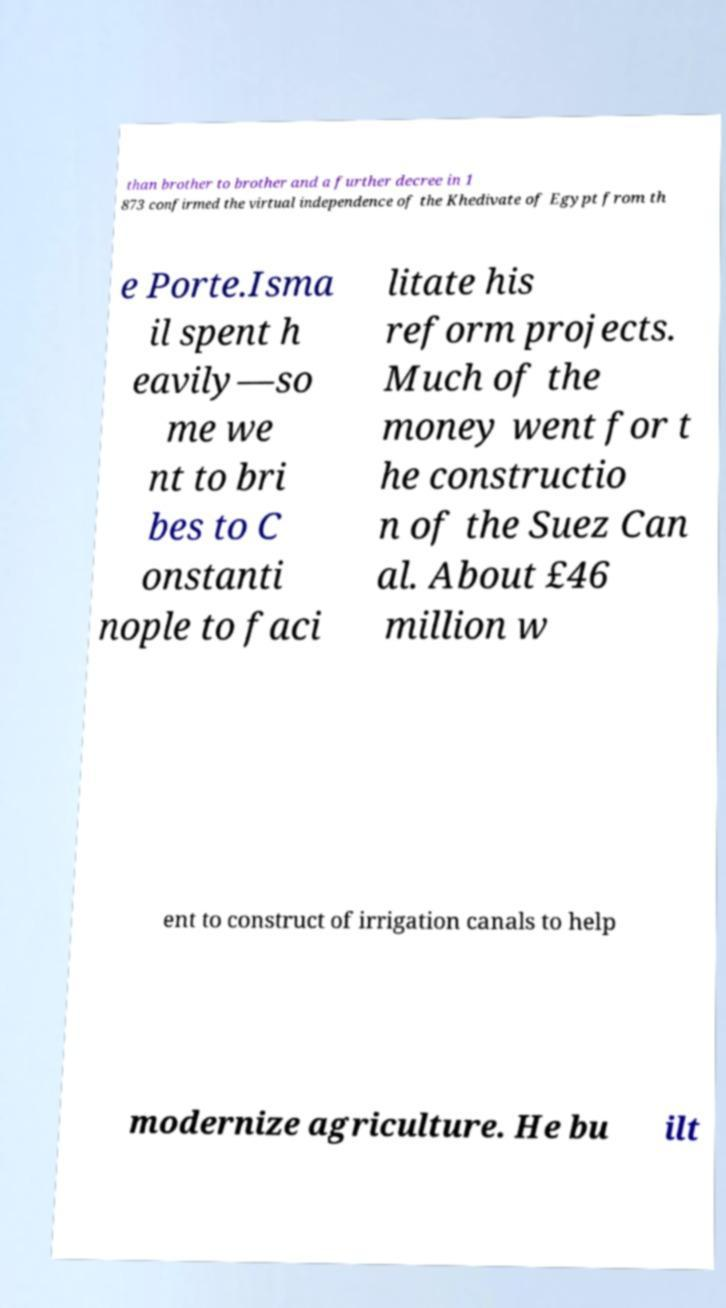Could you extract and type out the text from this image? than brother to brother and a further decree in 1 873 confirmed the virtual independence of the Khedivate of Egypt from th e Porte.Isma il spent h eavily—so me we nt to bri bes to C onstanti nople to faci litate his reform projects. Much of the money went for t he constructio n of the Suez Can al. About £46 million w ent to construct of irrigation canals to help modernize agriculture. He bu ilt 